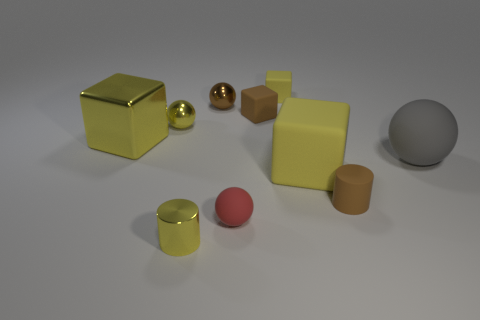How many other things are there of the same color as the tiny metallic cylinder?
Provide a short and direct response. 4. There is a small shiny cylinder; is it the same color as the big cube that is behind the large gray thing?
Your answer should be very brief. Yes. How many objects are either shiny cylinders or small yellow things behind the rubber cylinder?
Provide a short and direct response. 3. Do the tiny yellow thing behind the yellow ball and the big yellow rubber object have the same shape?
Give a very brief answer. Yes. There is a yellow block that is in front of the big thing on the left side of the yellow cylinder; how many small spheres are in front of it?
Give a very brief answer. 1. What number of objects are brown rubber cubes or yellow cylinders?
Your response must be concise. 2. There is a red object; does it have the same shape as the tiny brown rubber object in front of the yellow shiny block?
Give a very brief answer. No. There is a tiny brown object in front of the large gray rubber object; what is its shape?
Your answer should be very brief. Cylinder. Do the red rubber thing and the tiny yellow rubber thing have the same shape?
Provide a succinct answer. No. What size is the yellow shiny thing that is the same shape as the big yellow matte object?
Offer a very short reply. Large. 